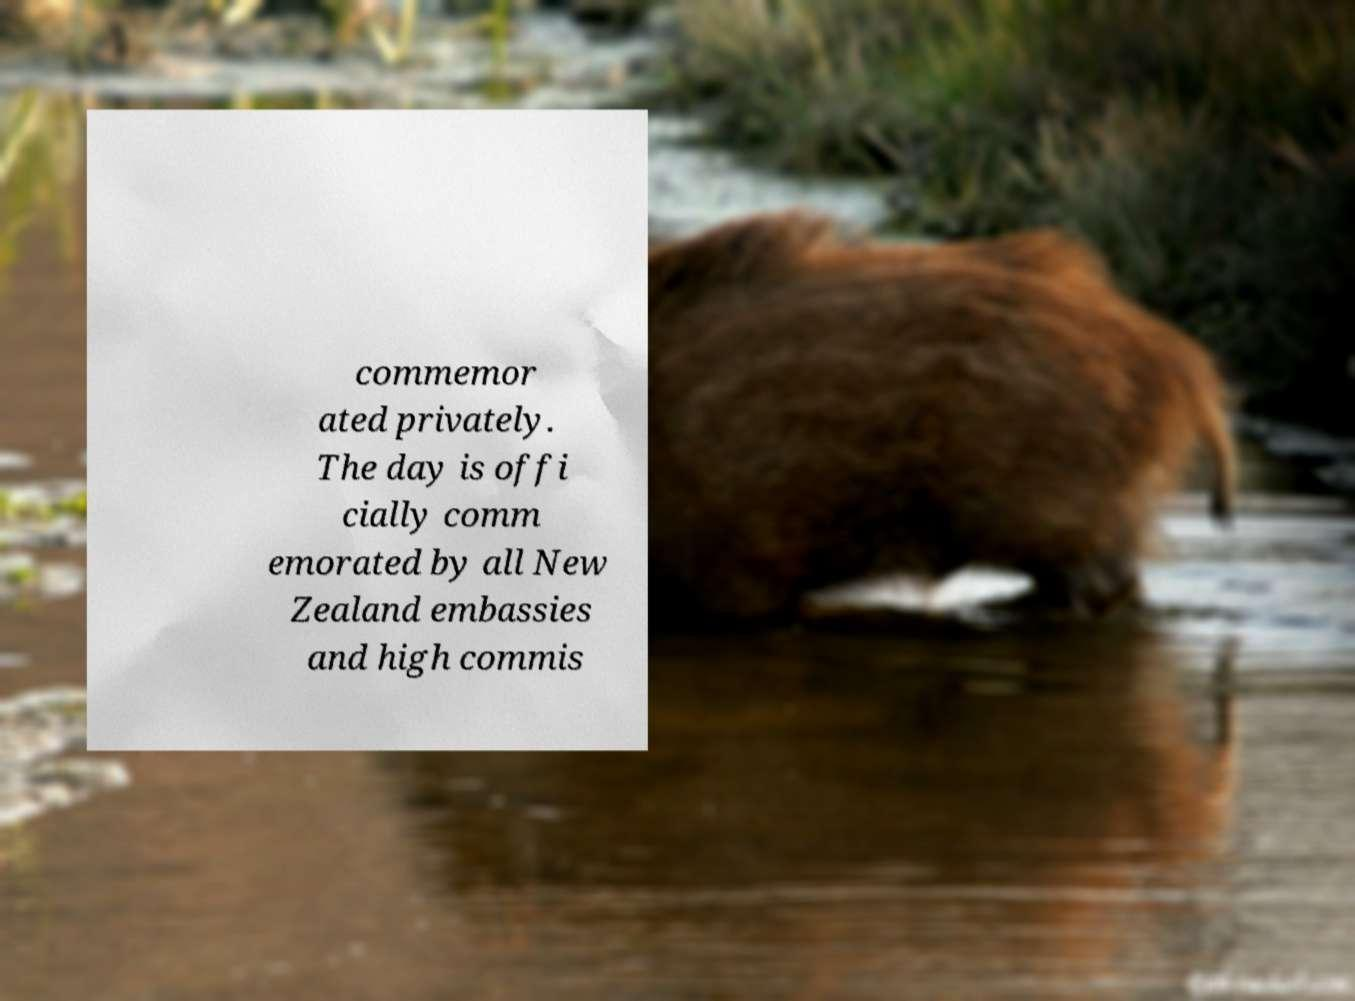Can you read and provide the text displayed in the image?This photo seems to have some interesting text. Can you extract and type it out for me? commemor ated privately. The day is offi cially comm emorated by all New Zealand embassies and high commis 